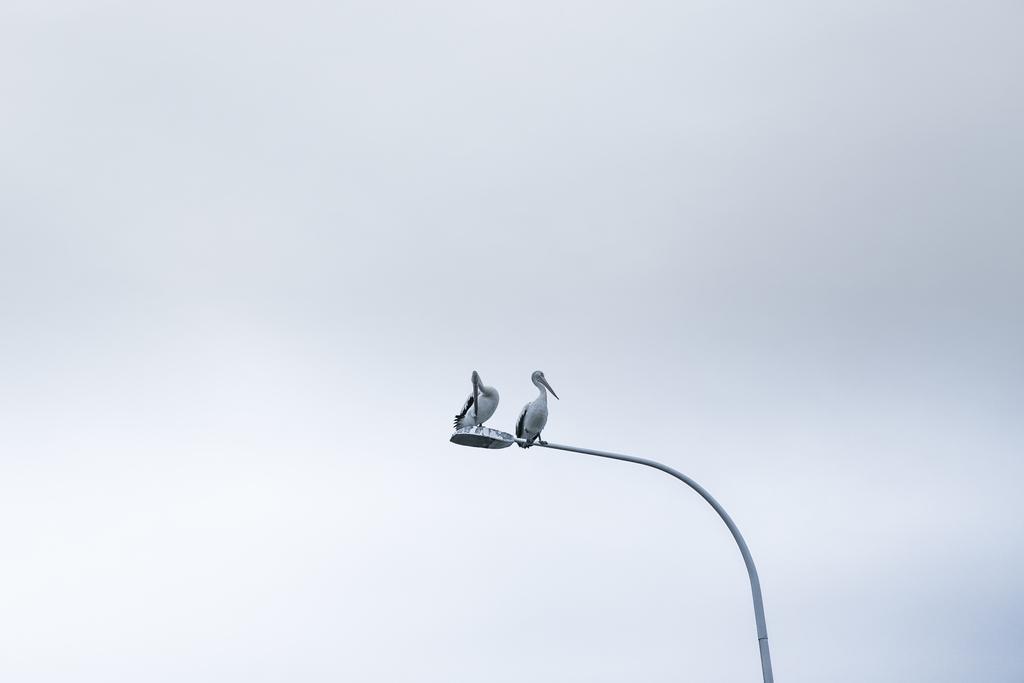How would you summarize this image in a sentence or two? This image consists of two birds sitting on a pole of street light. In the background, there is sky. 